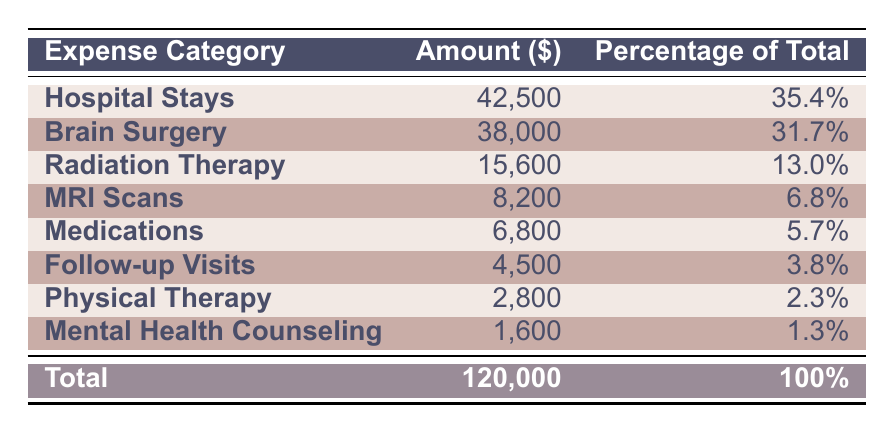What is the total amount of medical expenses listed in the table? The total amount of medical expenses is shown in the last row of the table. The value is 120,000.
Answer: 120,000 Which category has the highest expenses? The first row lists "Hospital Stays" as having the highest expenses at 42,500.
Answer: Hospital Stays What percentage of the total expenses is spent on medications? The table shows "Medications" correspond to 5,700% which is directly stated in the column for percentage.
Answer: 5.7% How much more is spent on brain surgery compared to follow-up visits? To find the difference, subtract the amount for follow-up visits (4,500) from the amount for brain surgery (38,000). This results in 38,000 - 4,500 = 33,500.
Answer: 33,500 Is the amount spent on physical therapy more than the amount spent on mental health counseling? The table shows that physical therapy costs 2,800 and mental health counseling costs 1,600. Since 2,800 is greater than 1,600, the answer is yes.
Answer: Yes What is the combined total of expenses for radiation therapy and MRI scans? To find the combined total, add the amount for radiation therapy (15,600) to the amount for MRI scans (8,200). The calculation is 15,600 + 8,200 = 23,800.
Answer: 23,800 What percentage of total expenses do the hospital stays and brain surgery account for together? To find the combined percentage, add the percentage values of hospital stays (35.4%) and brain surgery (31.7%). The total percentage is 35.4 + 31.7 = 67.1%.
Answer: 67.1% How much less is spent on radiation therapy compared to total medical expenses? The total expenses are 120,000 and radiation therapy is 15,600. To find the difference, subtract 15,600 from 120,000, resulting in 120,000 - 15,600 = 104,400.
Answer: 104,400 Which two categories combined make up less than 10% of the total expenses? Looking at the table, the categories "Physical Therapy" (2.3%) and "Mental Health Counseling" (1.3%) combined make 2.3 + 1.3 = 3.6%, which is less than 10%.
Answer: Physical Therapy and Mental Health Counseling 